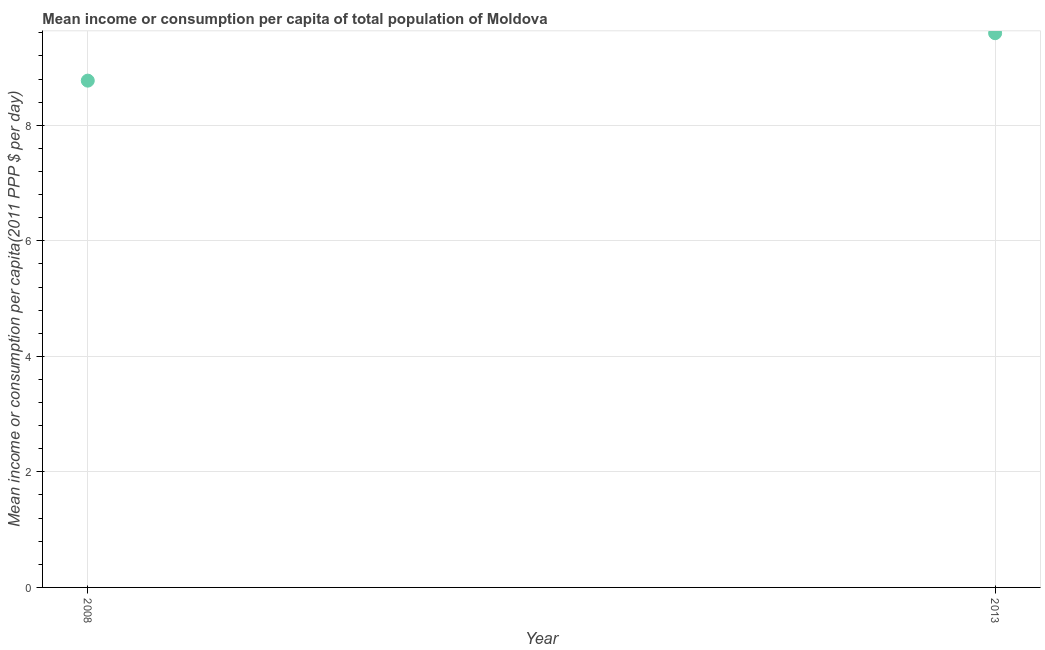What is the mean income or consumption in 2013?
Ensure brevity in your answer.  9.59. Across all years, what is the maximum mean income or consumption?
Keep it short and to the point. 9.59. Across all years, what is the minimum mean income or consumption?
Offer a very short reply. 8.77. In which year was the mean income or consumption maximum?
Make the answer very short. 2013. In which year was the mean income or consumption minimum?
Offer a terse response. 2008. What is the sum of the mean income or consumption?
Offer a very short reply. 18.37. What is the difference between the mean income or consumption in 2008 and 2013?
Provide a short and direct response. -0.82. What is the average mean income or consumption per year?
Provide a short and direct response. 9.18. What is the median mean income or consumption?
Make the answer very short. 9.18. What is the ratio of the mean income or consumption in 2008 to that in 2013?
Your answer should be compact. 0.91. Is the mean income or consumption in 2008 less than that in 2013?
Make the answer very short. Yes. In how many years, is the mean income or consumption greater than the average mean income or consumption taken over all years?
Provide a succinct answer. 1. How many dotlines are there?
Offer a terse response. 1. How many years are there in the graph?
Your response must be concise. 2. Are the values on the major ticks of Y-axis written in scientific E-notation?
Your answer should be very brief. No. Does the graph contain grids?
Your response must be concise. Yes. What is the title of the graph?
Offer a terse response. Mean income or consumption per capita of total population of Moldova. What is the label or title of the X-axis?
Make the answer very short. Year. What is the label or title of the Y-axis?
Ensure brevity in your answer.  Mean income or consumption per capita(2011 PPP $ per day). What is the Mean income or consumption per capita(2011 PPP $ per day) in 2008?
Provide a short and direct response. 8.77. What is the Mean income or consumption per capita(2011 PPP $ per day) in 2013?
Ensure brevity in your answer.  9.59. What is the difference between the Mean income or consumption per capita(2011 PPP $ per day) in 2008 and 2013?
Provide a succinct answer. -0.82. What is the ratio of the Mean income or consumption per capita(2011 PPP $ per day) in 2008 to that in 2013?
Keep it short and to the point. 0.91. 